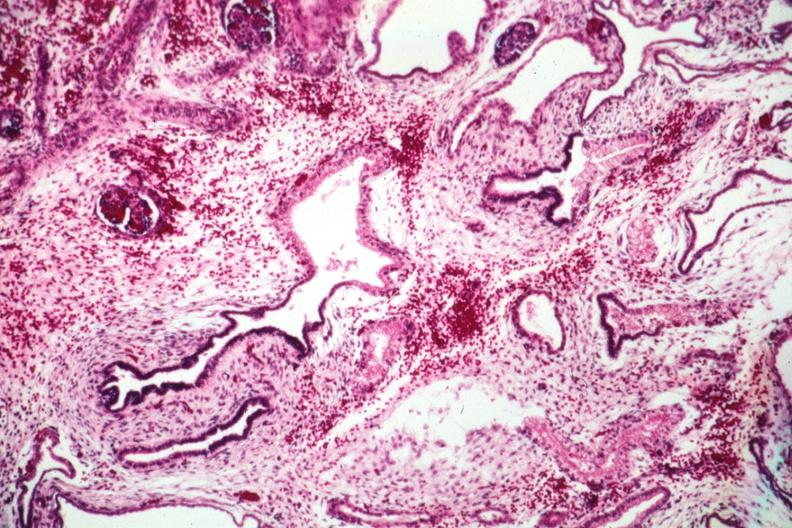what is present?
Answer the question using a single word or phrase. Polycystic disease infant 